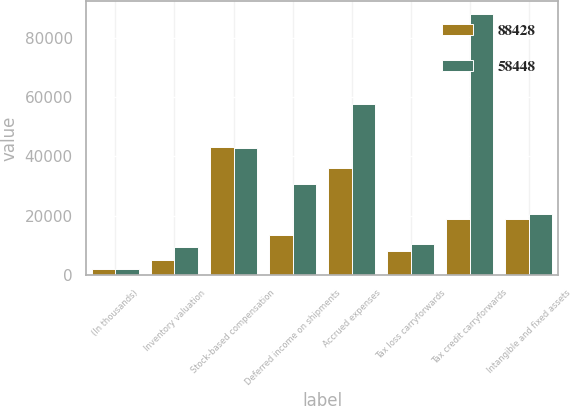<chart> <loc_0><loc_0><loc_500><loc_500><stacked_bar_chart><ecel><fcel>(In thousands)<fcel>Inventory valuation<fcel>Stock-based compensation<fcel>Deferred income on shipments<fcel>Accrued expenses<fcel>Tax loss carryforwards<fcel>Tax credit carryforwards<fcel>Intangible and fixed assets<nl><fcel>88428<fcel>2009<fcel>5116<fcel>43316<fcel>13567<fcel>36016<fcel>8204<fcel>18782<fcel>18782<nl><fcel>58448<fcel>2008<fcel>9569<fcel>42760<fcel>30733<fcel>57563<fcel>10403<fcel>88123<fcel>20612<nl></chart> 